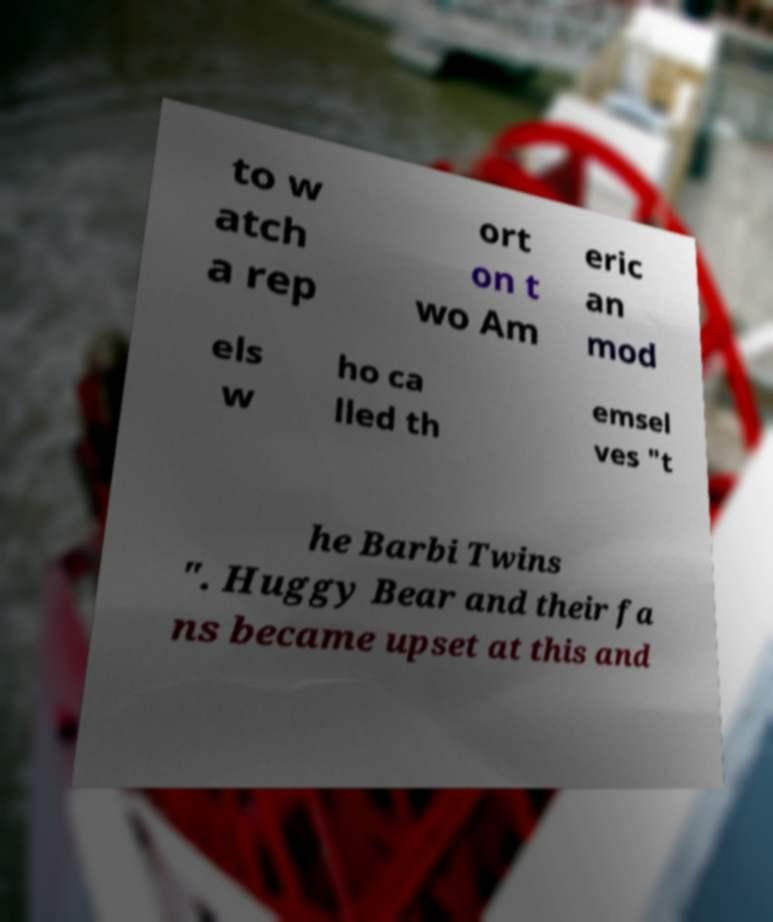Please identify and transcribe the text found in this image. to w atch a rep ort on t wo Am eric an mod els w ho ca lled th emsel ves "t he Barbi Twins ". Huggy Bear and their fa ns became upset at this and 